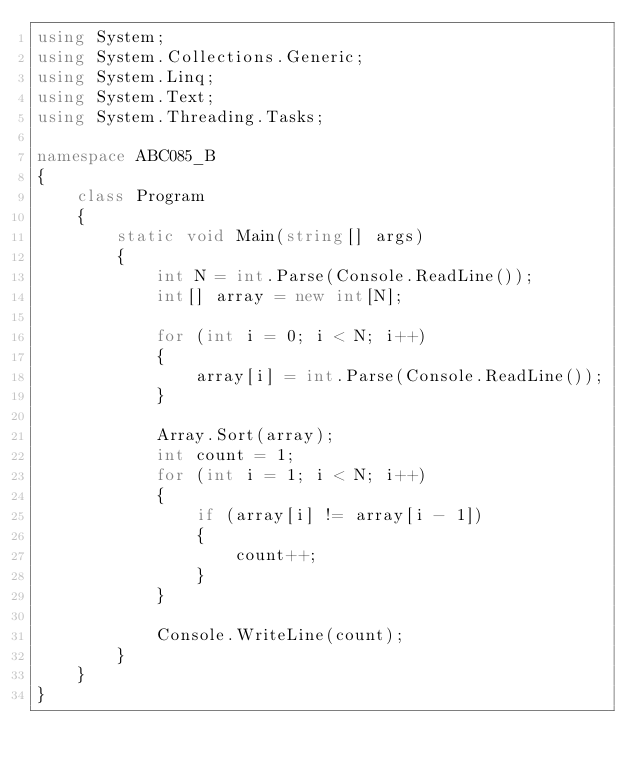Convert code to text. <code><loc_0><loc_0><loc_500><loc_500><_C#_>using System;
using System.Collections.Generic;
using System.Linq;
using System.Text;
using System.Threading.Tasks;

namespace ABC085_B
{
    class Program
    {
        static void Main(string[] args)
        {
            int N = int.Parse(Console.ReadLine());
            int[] array = new int[N];

            for (int i = 0; i < N; i++)
            {
                array[i] = int.Parse(Console.ReadLine());
            }

            Array.Sort(array);
            int count = 1;
            for (int i = 1; i < N; i++)
            {
                if (array[i] != array[i - 1])
                {
                    count++;
                }
            }

            Console.WriteLine(count);
        }
    }
}
</code> 